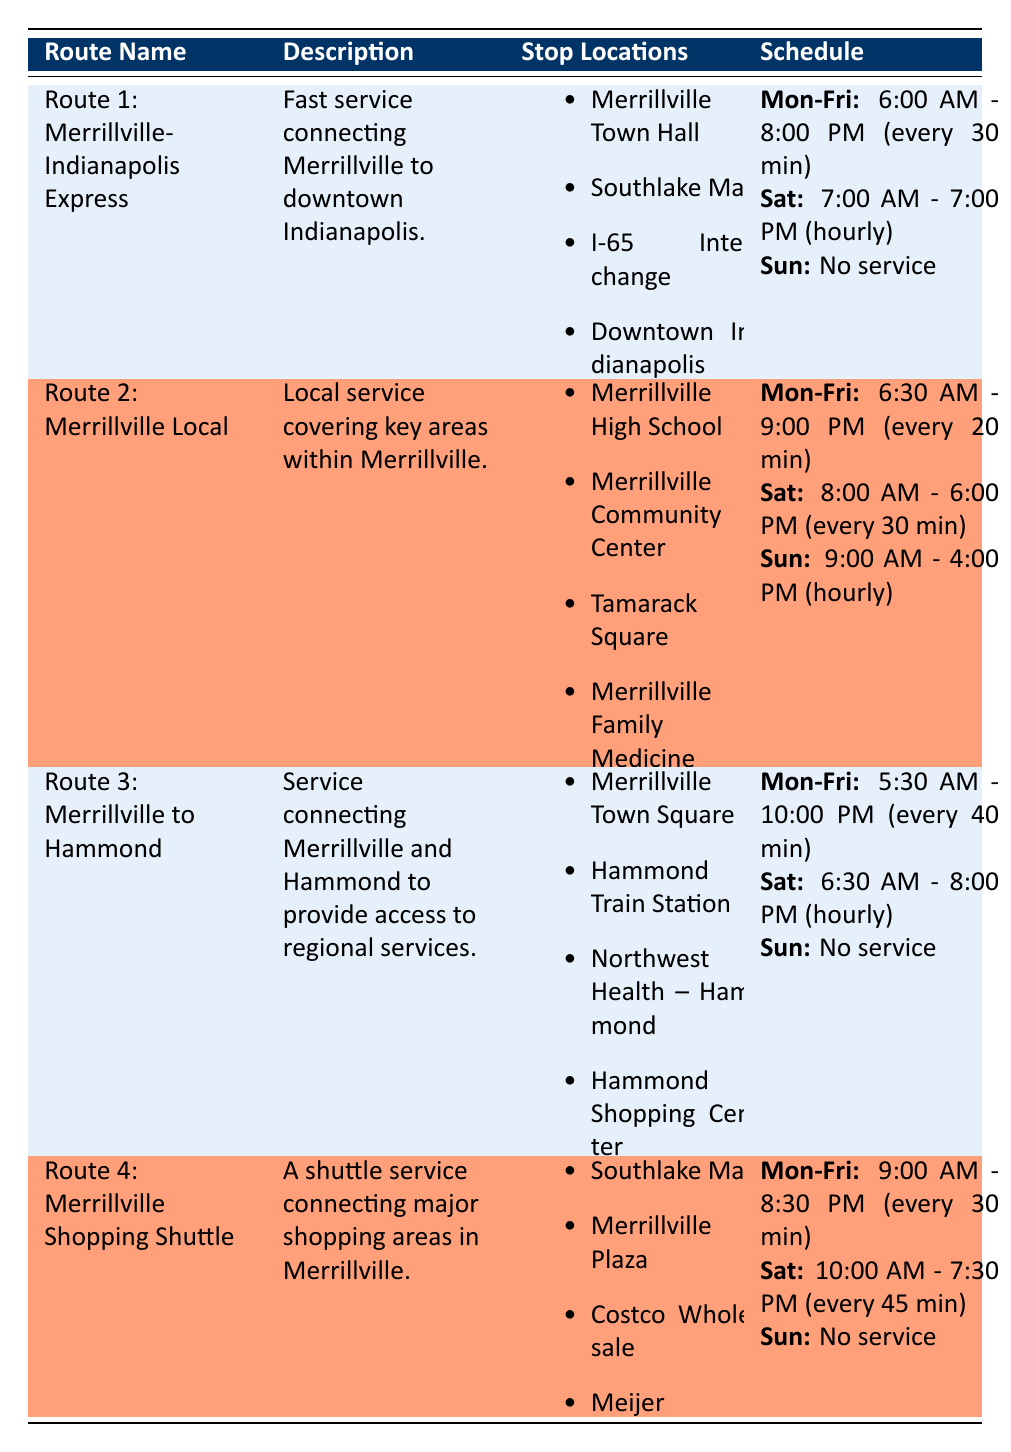What are the stop locations for Route 1? The stop locations for Route 1: Merrillville-Indianapolis Express are listed in the second column of the table. They include Merrillville Town Hall, Southlake Mall, I-65 Interchange, and Downtown Indianapolis.
Answer: Merrillville Town Hall, Southlake Mall, I-65 Interchange, Downtown Indianapolis Does Route 3 operate on Sundays? In the Sunday schedule for Route 3, it is stated that there is "No service." This means Route 3 does not operate at all on Sundays.
Answer: No What is the frequency of service for Route 2 on Saturdays? The frequency of service for Route 2 on Saturdays is specified in the schedule under the Saturday section. It states that the first departure is at 8:00 AM and the last at 6:00 PM, with a frequency of every 30 minutes.
Answer: Every 30 minutes How much time does Route 4 operate on weekdays? To find the operating hours for Route 4 on weekdays, we look at the schedule in the Monday to Friday section. The first departure is at 9:00 AM and the last departure is at 8:30 PM. The total operating time is from 9:00 AM to 8:30 PM, which is 11.5 hours.
Answer: 11.5 hours Which route has the earliest first departure time on weekdays? We need to compare the first departure times for all routes on weekdays. Route 3 has its first departure at 5:30 AM, Route 1 at 6:00 AM, Route 2 at 6:30 AM, and Route 4 at 9:00 AM. The earliest first departure is 5:30 AM for Route 3.
Answer: Route 3 What is the last departure for the Merrillville Shopping Shuttle on Saturdays? The schedule for the Merrillville Shopping Shuttle indicates that on Saturdays, the last departure is at 7:30 PM. This information is found under the Saturday schedule for Route 4.
Answer: 7:30 PM Are there more service options on Saturdays compared to Sundays? By examining the table, we see that several routes operate on Saturdays, while each route indicates "No service" on Sundays. This means there are indeed more options on Saturdays.
Answer: Yes What is the average frequency of service for all routes on weekdays? To calculate the average frequency of service on weekdays, we first identify the frequencies: Route 1 is every 30 minutes, Route 2 is every 20 minutes, Route 3 is every 40 minutes, and Route 4 is every 30 minutes. We convert these to minutes: 30, 20, 40, 30 respectively, sum them (30 + 20 + 40 + 30 = 120), and divide by 4 for the average. The average frequency is 120/4 = 30 minutes on weekdays.
Answer: 30 minutes 